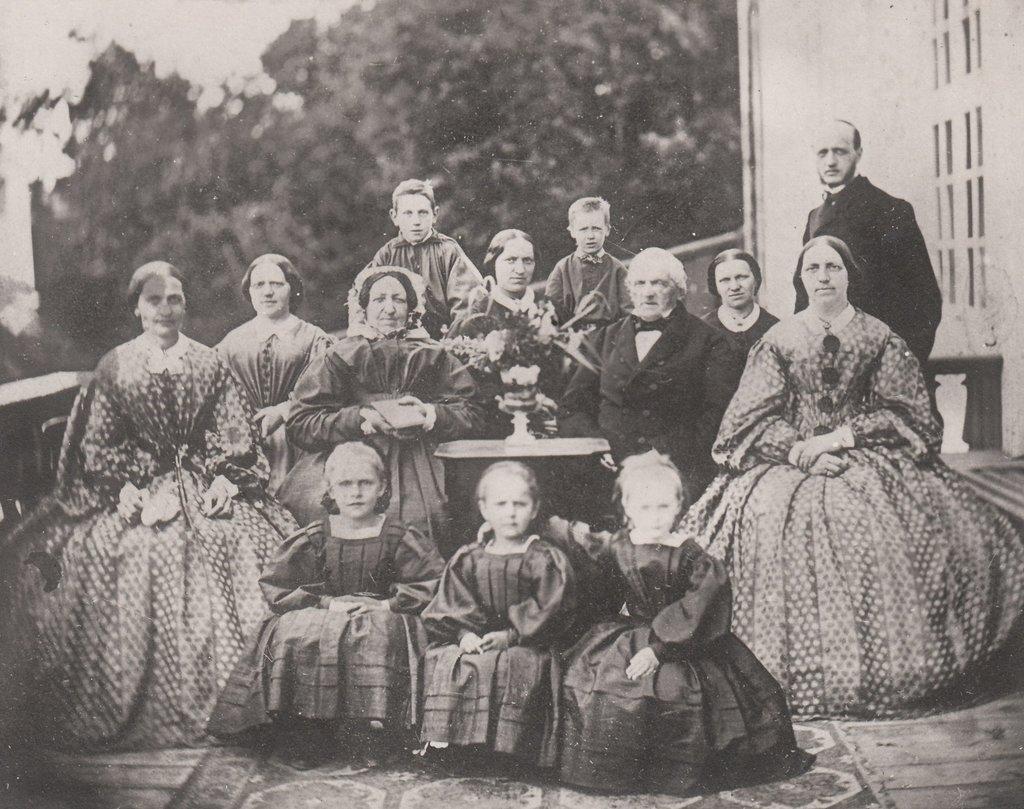Describe this image in one or two sentences. In this image we can see group of persons sitting and posing for a photograph, at the middle of the image there is flower vase on the table and at the background of the image there are some trees and building. 